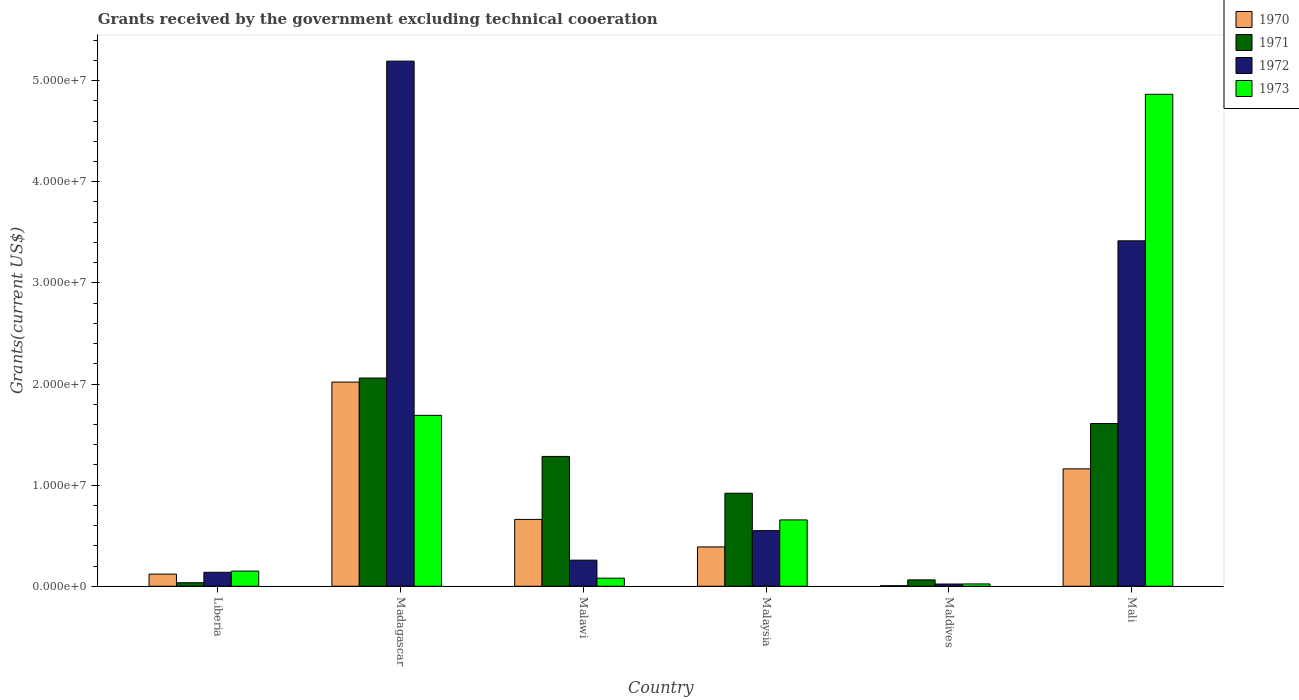How many groups of bars are there?
Keep it short and to the point. 6. Are the number of bars on each tick of the X-axis equal?
Make the answer very short. Yes. What is the label of the 3rd group of bars from the left?
Offer a terse response. Malawi. What is the total grants received by the government in 1972 in Liberia?
Keep it short and to the point. 1.38e+06. Across all countries, what is the maximum total grants received by the government in 1972?
Your response must be concise. 5.19e+07. Across all countries, what is the minimum total grants received by the government in 1970?
Your answer should be compact. 6.00e+04. In which country was the total grants received by the government in 1971 maximum?
Give a very brief answer. Madagascar. In which country was the total grants received by the government in 1970 minimum?
Your response must be concise. Maldives. What is the total total grants received by the government in 1973 in the graph?
Offer a terse response. 7.46e+07. What is the difference between the total grants received by the government in 1972 in Madagascar and that in Malawi?
Ensure brevity in your answer.  4.94e+07. What is the difference between the total grants received by the government in 1971 in Madagascar and the total grants received by the government in 1972 in Maldives?
Ensure brevity in your answer.  2.04e+07. What is the average total grants received by the government in 1970 per country?
Your answer should be very brief. 7.26e+06. What is the difference between the total grants received by the government of/in 1970 and total grants received by the government of/in 1972 in Mali?
Keep it short and to the point. -2.26e+07. In how many countries, is the total grants received by the government in 1973 greater than 28000000 US$?
Your answer should be very brief. 1. What is the ratio of the total grants received by the government in 1970 in Liberia to that in Malaysia?
Your answer should be very brief. 0.31. What is the difference between the highest and the second highest total grants received by the government in 1972?
Ensure brevity in your answer.  4.64e+07. What is the difference between the highest and the lowest total grants received by the government in 1972?
Ensure brevity in your answer.  5.17e+07. In how many countries, is the total grants received by the government in 1972 greater than the average total grants received by the government in 1972 taken over all countries?
Offer a terse response. 2. Is the sum of the total grants received by the government in 1972 in Madagascar and Maldives greater than the maximum total grants received by the government in 1971 across all countries?
Your answer should be very brief. Yes. Is it the case that in every country, the sum of the total grants received by the government in 1972 and total grants received by the government in 1971 is greater than the total grants received by the government in 1970?
Keep it short and to the point. Yes. Are the values on the major ticks of Y-axis written in scientific E-notation?
Give a very brief answer. Yes. Does the graph contain any zero values?
Provide a succinct answer. No. Does the graph contain grids?
Provide a succinct answer. No. How many legend labels are there?
Keep it short and to the point. 4. How are the legend labels stacked?
Keep it short and to the point. Vertical. What is the title of the graph?
Provide a succinct answer. Grants received by the government excluding technical cooeration. Does "1999" appear as one of the legend labels in the graph?
Provide a succinct answer. No. What is the label or title of the Y-axis?
Ensure brevity in your answer.  Grants(current US$). What is the Grants(current US$) in 1970 in Liberia?
Offer a very short reply. 1.20e+06. What is the Grants(current US$) in 1972 in Liberia?
Provide a succinct answer. 1.38e+06. What is the Grants(current US$) in 1973 in Liberia?
Your response must be concise. 1.50e+06. What is the Grants(current US$) of 1970 in Madagascar?
Give a very brief answer. 2.02e+07. What is the Grants(current US$) in 1971 in Madagascar?
Keep it short and to the point. 2.06e+07. What is the Grants(current US$) in 1972 in Madagascar?
Ensure brevity in your answer.  5.19e+07. What is the Grants(current US$) in 1973 in Madagascar?
Offer a terse response. 1.69e+07. What is the Grants(current US$) of 1970 in Malawi?
Keep it short and to the point. 6.61e+06. What is the Grants(current US$) in 1971 in Malawi?
Make the answer very short. 1.28e+07. What is the Grants(current US$) in 1972 in Malawi?
Offer a very short reply. 2.58e+06. What is the Grants(current US$) in 1973 in Malawi?
Provide a short and direct response. 8.00e+05. What is the Grants(current US$) of 1970 in Malaysia?
Your answer should be very brief. 3.89e+06. What is the Grants(current US$) in 1971 in Malaysia?
Provide a short and direct response. 9.20e+06. What is the Grants(current US$) of 1972 in Malaysia?
Make the answer very short. 5.50e+06. What is the Grants(current US$) of 1973 in Malaysia?
Offer a very short reply. 6.56e+06. What is the Grants(current US$) of 1971 in Maldives?
Make the answer very short. 6.30e+05. What is the Grants(current US$) in 1972 in Maldives?
Provide a succinct answer. 2.20e+05. What is the Grants(current US$) of 1970 in Mali?
Give a very brief answer. 1.16e+07. What is the Grants(current US$) of 1971 in Mali?
Your response must be concise. 1.61e+07. What is the Grants(current US$) in 1972 in Mali?
Make the answer very short. 3.42e+07. What is the Grants(current US$) of 1973 in Mali?
Keep it short and to the point. 4.86e+07. Across all countries, what is the maximum Grants(current US$) in 1970?
Your answer should be compact. 2.02e+07. Across all countries, what is the maximum Grants(current US$) in 1971?
Your answer should be very brief. 2.06e+07. Across all countries, what is the maximum Grants(current US$) in 1972?
Offer a very short reply. 5.19e+07. Across all countries, what is the maximum Grants(current US$) in 1973?
Ensure brevity in your answer.  4.86e+07. Across all countries, what is the minimum Grants(current US$) of 1970?
Provide a short and direct response. 6.00e+04. Across all countries, what is the minimum Grants(current US$) of 1971?
Your answer should be compact. 3.50e+05. Across all countries, what is the minimum Grants(current US$) of 1973?
Provide a succinct answer. 2.30e+05. What is the total Grants(current US$) of 1970 in the graph?
Keep it short and to the point. 4.36e+07. What is the total Grants(current US$) of 1971 in the graph?
Make the answer very short. 5.97e+07. What is the total Grants(current US$) in 1972 in the graph?
Your response must be concise. 9.58e+07. What is the total Grants(current US$) of 1973 in the graph?
Offer a terse response. 7.46e+07. What is the difference between the Grants(current US$) in 1970 in Liberia and that in Madagascar?
Provide a short and direct response. -1.90e+07. What is the difference between the Grants(current US$) of 1971 in Liberia and that in Madagascar?
Your answer should be very brief. -2.02e+07. What is the difference between the Grants(current US$) in 1972 in Liberia and that in Madagascar?
Your answer should be compact. -5.06e+07. What is the difference between the Grants(current US$) in 1973 in Liberia and that in Madagascar?
Keep it short and to the point. -1.54e+07. What is the difference between the Grants(current US$) in 1970 in Liberia and that in Malawi?
Offer a very short reply. -5.41e+06. What is the difference between the Grants(current US$) in 1971 in Liberia and that in Malawi?
Ensure brevity in your answer.  -1.25e+07. What is the difference between the Grants(current US$) in 1972 in Liberia and that in Malawi?
Offer a terse response. -1.20e+06. What is the difference between the Grants(current US$) in 1970 in Liberia and that in Malaysia?
Provide a succinct answer. -2.69e+06. What is the difference between the Grants(current US$) of 1971 in Liberia and that in Malaysia?
Offer a very short reply. -8.85e+06. What is the difference between the Grants(current US$) in 1972 in Liberia and that in Malaysia?
Provide a succinct answer. -4.12e+06. What is the difference between the Grants(current US$) of 1973 in Liberia and that in Malaysia?
Give a very brief answer. -5.06e+06. What is the difference between the Grants(current US$) in 1970 in Liberia and that in Maldives?
Ensure brevity in your answer.  1.14e+06. What is the difference between the Grants(current US$) in 1971 in Liberia and that in Maldives?
Keep it short and to the point. -2.80e+05. What is the difference between the Grants(current US$) of 1972 in Liberia and that in Maldives?
Ensure brevity in your answer.  1.16e+06. What is the difference between the Grants(current US$) of 1973 in Liberia and that in Maldives?
Keep it short and to the point. 1.27e+06. What is the difference between the Grants(current US$) of 1970 in Liberia and that in Mali?
Offer a very short reply. -1.04e+07. What is the difference between the Grants(current US$) of 1971 in Liberia and that in Mali?
Give a very brief answer. -1.57e+07. What is the difference between the Grants(current US$) in 1972 in Liberia and that in Mali?
Give a very brief answer. -3.28e+07. What is the difference between the Grants(current US$) of 1973 in Liberia and that in Mali?
Your answer should be compact. -4.72e+07. What is the difference between the Grants(current US$) in 1970 in Madagascar and that in Malawi?
Make the answer very short. 1.36e+07. What is the difference between the Grants(current US$) of 1971 in Madagascar and that in Malawi?
Provide a short and direct response. 7.75e+06. What is the difference between the Grants(current US$) of 1972 in Madagascar and that in Malawi?
Offer a terse response. 4.94e+07. What is the difference between the Grants(current US$) of 1973 in Madagascar and that in Malawi?
Ensure brevity in your answer.  1.61e+07. What is the difference between the Grants(current US$) of 1970 in Madagascar and that in Malaysia?
Give a very brief answer. 1.63e+07. What is the difference between the Grants(current US$) in 1971 in Madagascar and that in Malaysia?
Your answer should be very brief. 1.14e+07. What is the difference between the Grants(current US$) of 1972 in Madagascar and that in Malaysia?
Give a very brief answer. 4.64e+07. What is the difference between the Grants(current US$) of 1973 in Madagascar and that in Malaysia?
Your answer should be compact. 1.03e+07. What is the difference between the Grants(current US$) in 1970 in Madagascar and that in Maldives?
Offer a very short reply. 2.01e+07. What is the difference between the Grants(current US$) of 1971 in Madagascar and that in Maldives?
Offer a terse response. 2.00e+07. What is the difference between the Grants(current US$) in 1972 in Madagascar and that in Maldives?
Give a very brief answer. 5.17e+07. What is the difference between the Grants(current US$) in 1973 in Madagascar and that in Maldives?
Your response must be concise. 1.67e+07. What is the difference between the Grants(current US$) in 1970 in Madagascar and that in Mali?
Make the answer very short. 8.58e+06. What is the difference between the Grants(current US$) of 1971 in Madagascar and that in Mali?
Your answer should be compact. 4.50e+06. What is the difference between the Grants(current US$) of 1972 in Madagascar and that in Mali?
Provide a succinct answer. 1.78e+07. What is the difference between the Grants(current US$) of 1973 in Madagascar and that in Mali?
Offer a terse response. -3.18e+07. What is the difference between the Grants(current US$) of 1970 in Malawi and that in Malaysia?
Your answer should be compact. 2.72e+06. What is the difference between the Grants(current US$) of 1971 in Malawi and that in Malaysia?
Offer a very short reply. 3.64e+06. What is the difference between the Grants(current US$) of 1972 in Malawi and that in Malaysia?
Offer a terse response. -2.92e+06. What is the difference between the Grants(current US$) of 1973 in Malawi and that in Malaysia?
Offer a very short reply. -5.76e+06. What is the difference between the Grants(current US$) in 1970 in Malawi and that in Maldives?
Your response must be concise. 6.55e+06. What is the difference between the Grants(current US$) in 1971 in Malawi and that in Maldives?
Provide a short and direct response. 1.22e+07. What is the difference between the Grants(current US$) in 1972 in Malawi and that in Maldives?
Provide a succinct answer. 2.36e+06. What is the difference between the Grants(current US$) of 1973 in Malawi and that in Maldives?
Ensure brevity in your answer.  5.70e+05. What is the difference between the Grants(current US$) in 1970 in Malawi and that in Mali?
Your response must be concise. -5.00e+06. What is the difference between the Grants(current US$) of 1971 in Malawi and that in Mali?
Your answer should be compact. -3.25e+06. What is the difference between the Grants(current US$) of 1972 in Malawi and that in Mali?
Your answer should be compact. -3.16e+07. What is the difference between the Grants(current US$) in 1973 in Malawi and that in Mali?
Your answer should be very brief. -4.78e+07. What is the difference between the Grants(current US$) of 1970 in Malaysia and that in Maldives?
Keep it short and to the point. 3.83e+06. What is the difference between the Grants(current US$) in 1971 in Malaysia and that in Maldives?
Your answer should be compact. 8.57e+06. What is the difference between the Grants(current US$) in 1972 in Malaysia and that in Maldives?
Provide a succinct answer. 5.28e+06. What is the difference between the Grants(current US$) of 1973 in Malaysia and that in Maldives?
Provide a short and direct response. 6.33e+06. What is the difference between the Grants(current US$) in 1970 in Malaysia and that in Mali?
Offer a terse response. -7.72e+06. What is the difference between the Grants(current US$) of 1971 in Malaysia and that in Mali?
Offer a terse response. -6.89e+06. What is the difference between the Grants(current US$) in 1972 in Malaysia and that in Mali?
Offer a very short reply. -2.87e+07. What is the difference between the Grants(current US$) in 1973 in Malaysia and that in Mali?
Ensure brevity in your answer.  -4.21e+07. What is the difference between the Grants(current US$) of 1970 in Maldives and that in Mali?
Your response must be concise. -1.16e+07. What is the difference between the Grants(current US$) of 1971 in Maldives and that in Mali?
Provide a short and direct response. -1.55e+07. What is the difference between the Grants(current US$) of 1972 in Maldives and that in Mali?
Offer a very short reply. -3.39e+07. What is the difference between the Grants(current US$) of 1973 in Maldives and that in Mali?
Your answer should be compact. -4.84e+07. What is the difference between the Grants(current US$) of 1970 in Liberia and the Grants(current US$) of 1971 in Madagascar?
Keep it short and to the point. -1.94e+07. What is the difference between the Grants(current US$) in 1970 in Liberia and the Grants(current US$) in 1972 in Madagascar?
Offer a very short reply. -5.07e+07. What is the difference between the Grants(current US$) of 1970 in Liberia and the Grants(current US$) of 1973 in Madagascar?
Give a very brief answer. -1.57e+07. What is the difference between the Grants(current US$) in 1971 in Liberia and the Grants(current US$) in 1972 in Madagascar?
Your answer should be very brief. -5.16e+07. What is the difference between the Grants(current US$) of 1971 in Liberia and the Grants(current US$) of 1973 in Madagascar?
Provide a succinct answer. -1.66e+07. What is the difference between the Grants(current US$) in 1972 in Liberia and the Grants(current US$) in 1973 in Madagascar?
Your response must be concise. -1.55e+07. What is the difference between the Grants(current US$) in 1970 in Liberia and the Grants(current US$) in 1971 in Malawi?
Offer a very short reply. -1.16e+07. What is the difference between the Grants(current US$) of 1970 in Liberia and the Grants(current US$) of 1972 in Malawi?
Your answer should be very brief. -1.38e+06. What is the difference between the Grants(current US$) in 1971 in Liberia and the Grants(current US$) in 1972 in Malawi?
Make the answer very short. -2.23e+06. What is the difference between the Grants(current US$) of 1971 in Liberia and the Grants(current US$) of 1973 in Malawi?
Your answer should be very brief. -4.50e+05. What is the difference between the Grants(current US$) in 1972 in Liberia and the Grants(current US$) in 1973 in Malawi?
Keep it short and to the point. 5.80e+05. What is the difference between the Grants(current US$) of 1970 in Liberia and the Grants(current US$) of 1971 in Malaysia?
Your answer should be compact. -8.00e+06. What is the difference between the Grants(current US$) of 1970 in Liberia and the Grants(current US$) of 1972 in Malaysia?
Your answer should be very brief. -4.30e+06. What is the difference between the Grants(current US$) in 1970 in Liberia and the Grants(current US$) in 1973 in Malaysia?
Your answer should be very brief. -5.36e+06. What is the difference between the Grants(current US$) of 1971 in Liberia and the Grants(current US$) of 1972 in Malaysia?
Your response must be concise. -5.15e+06. What is the difference between the Grants(current US$) in 1971 in Liberia and the Grants(current US$) in 1973 in Malaysia?
Make the answer very short. -6.21e+06. What is the difference between the Grants(current US$) in 1972 in Liberia and the Grants(current US$) in 1973 in Malaysia?
Give a very brief answer. -5.18e+06. What is the difference between the Grants(current US$) of 1970 in Liberia and the Grants(current US$) of 1971 in Maldives?
Offer a terse response. 5.70e+05. What is the difference between the Grants(current US$) of 1970 in Liberia and the Grants(current US$) of 1972 in Maldives?
Ensure brevity in your answer.  9.80e+05. What is the difference between the Grants(current US$) in 1970 in Liberia and the Grants(current US$) in 1973 in Maldives?
Your answer should be very brief. 9.70e+05. What is the difference between the Grants(current US$) in 1971 in Liberia and the Grants(current US$) in 1972 in Maldives?
Offer a very short reply. 1.30e+05. What is the difference between the Grants(current US$) of 1971 in Liberia and the Grants(current US$) of 1973 in Maldives?
Make the answer very short. 1.20e+05. What is the difference between the Grants(current US$) of 1972 in Liberia and the Grants(current US$) of 1973 in Maldives?
Your answer should be very brief. 1.15e+06. What is the difference between the Grants(current US$) of 1970 in Liberia and the Grants(current US$) of 1971 in Mali?
Make the answer very short. -1.49e+07. What is the difference between the Grants(current US$) in 1970 in Liberia and the Grants(current US$) in 1972 in Mali?
Your answer should be very brief. -3.30e+07. What is the difference between the Grants(current US$) in 1970 in Liberia and the Grants(current US$) in 1973 in Mali?
Give a very brief answer. -4.74e+07. What is the difference between the Grants(current US$) of 1971 in Liberia and the Grants(current US$) of 1972 in Mali?
Your response must be concise. -3.38e+07. What is the difference between the Grants(current US$) of 1971 in Liberia and the Grants(current US$) of 1973 in Mali?
Make the answer very short. -4.83e+07. What is the difference between the Grants(current US$) in 1972 in Liberia and the Grants(current US$) in 1973 in Mali?
Your answer should be very brief. -4.73e+07. What is the difference between the Grants(current US$) of 1970 in Madagascar and the Grants(current US$) of 1971 in Malawi?
Offer a terse response. 7.35e+06. What is the difference between the Grants(current US$) in 1970 in Madagascar and the Grants(current US$) in 1972 in Malawi?
Provide a short and direct response. 1.76e+07. What is the difference between the Grants(current US$) of 1970 in Madagascar and the Grants(current US$) of 1973 in Malawi?
Ensure brevity in your answer.  1.94e+07. What is the difference between the Grants(current US$) in 1971 in Madagascar and the Grants(current US$) in 1972 in Malawi?
Provide a short and direct response. 1.80e+07. What is the difference between the Grants(current US$) in 1971 in Madagascar and the Grants(current US$) in 1973 in Malawi?
Provide a short and direct response. 1.98e+07. What is the difference between the Grants(current US$) in 1972 in Madagascar and the Grants(current US$) in 1973 in Malawi?
Make the answer very short. 5.11e+07. What is the difference between the Grants(current US$) of 1970 in Madagascar and the Grants(current US$) of 1971 in Malaysia?
Keep it short and to the point. 1.10e+07. What is the difference between the Grants(current US$) of 1970 in Madagascar and the Grants(current US$) of 1972 in Malaysia?
Your answer should be very brief. 1.47e+07. What is the difference between the Grants(current US$) of 1970 in Madagascar and the Grants(current US$) of 1973 in Malaysia?
Make the answer very short. 1.36e+07. What is the difference between the Grants(current US$) in 1971 in Madagascar and the Grants(current US$) in 1972 in Malaysia?
Ensure brevity in your answer.  1.51e+07. What is the difference between the Grants(current US$) of 1971 in Madagascar and the Grants(current US$) of 1973 in Malaysia?
Your answer should be very brief. 1.40e+07. What is the difference between the Grants(current US$) of 1972 in Madagascar and the Grants(current US$) of 1973 in Malaysia?
Offer a terse response. 4.54e+07. What is the difference between the Grants(current US$) of 1970 in Madagascar and the Grants(current US$) of 1971 in Maldives?
Your answer should be compact. 1.96e+07. What is the difference between the Grants(current US$) in 1970 in Madagascar and the Grants(current US$) in 1972 in Maldives?
Your response must be concise. 2.00e+07. What is the difference between the Grants(current US$) in 1970 in Madagascar and the Grants(current US$) in 1973 in Maldives?
Provide a succinct answer. 2.00e+07. What is the difference between the Grants(current US$) of 1971 in Madagascar and the Grants(current US$) of 1972 in Maldives?
Keep it short and to the point. 2.04e+07. What is the difference between the Grants(current US$) of 1971 in Madagascar and the Grants(current US$) of 1973 in Maldives?
Your answer should be very brief. 2.04e+07. What is the difference between the Grants(current US$) in 1972 in Madagascar and the Grants(current US$) in 1973 in Maldives?
Keep it short and to the point. 5.17e+07. What is the difference between the Grants(current US$) of 1970 in Madagascar and the Grants(current US$) of 1971 in Mali?
Provide a short and direct response. 4.10e+06. What is the difference between the Grants(current US$) in 1970 in Madagascar and the Grants(current US$) in 1972 in Mali?
Your answer should be compact. -1.40e+07. What is the difference between the Grants(current US$) in 1970 in Madagascar and the Grants(current US$) in 1973 in Mali?
Your answer should be compact. -2.85e+07. What is the difference between the Grants(current US$) of 1971 in Madagascar and the Grants(current US$) of 1972 in Mali?
Your answer should be compact. -1.36e+07. What is the difference between the Grants(current US$) of 1971 in Madagascar and the Grants(current US$) of 1973 in Mali?
Your response must be concise. -2.81e+07. What is the difference between the Grants(current US$) of 1972 in Madagascar and the Grants(current US$) of 1973 in Mali?
Keep it short and to the point. 3.28e+06. What is the difference between the Grants(current US$) of 1970 in Malawi and the Grants(current US$) of 1971 in Malaysia?
Your response must be concise. -2.59e+06. What is the difference between the Grants(current US$) in 1970 in Malawi and the Grants(current US$) in 1972 in Malaysia?
Make the answer very short. 1.11e+06. What is the difference between the Grants(current US$) in 1970 in Malawi and the Grants(current US$) in 1973 in Malaysia?
Offer a terse response. 5.00e+04. What is the difference between the Grants(current US$) in 1971 in Malawi and the Grants(current US$) in 1972 in Malaysia?
Provide a succinct answer. 7.34e+06. What is the difference between the Grants(current US$) of 1971 in Malawi and the Grants(current US$) of 1973 in Malaysia?
Provide a short and direct response. 6.28e+06. What is the difference between the Grants(current US$) in 1972 in Malawi and the Grants(current US$) in 1973 in Malaysia?
Your answer should be very brief. -3.98e+06. What is the difference between the Grants(current US$) of 1970 in Malawi and the Grants(current US$) of 1971 in Maldives?
Offer a very short reply. 5.98e+06. What is the difference between the Grants(current US$) in 1970 in Malawi and the Grants(current US$) in 1972 in Maldives?
Offer a very short reply. 6.39e+06. What is the difference between the Grants(current US$) of 1970 in Malawi and the Grants(current US$) of 1973 in Maldives?
Give a very brief answer. 6.38e+06. What is the difference between the Grants(current US$) in 1971 in Malawi and the Grants(current US$) in 1972 in Maldives?
Ensure brevity in your answer.  1.26e+07. What is the difference between the Grants(current US$) in 1971 in Malawi and the Grants(current US$) in 1973 in Maldives?
Offer a very short reply. 1.26e+07. What is the difference between the Grants(current US$) of 1972 in Malawi and the Grants(current US$) of 1973 in Maldives?
Offer a terse response. 2.35e+06. What is the difference between the Grants(current US$) of 1970 in Malawi and the Grants(current US$) of 1971 in Mali?
Provide a short and direct response. -9.48e+06. What is the difference between the Grants(current US$) of 1970 in Malawi and the Grants(current US$) of 1972 in Mali?
Provide a succinct answer. -2.76e+07. What is the difference between the Grants(current US$) in 1970 in Malawi and the Grants(current US$) in 1973 in Mali?
Keep it short and to the point. -4.20e+07. What is the difference between the Grants(current US$) of 1971 in Malawi and the Grants(current US$) of 1972 in Mali?
Offer a very short reply. -2.13e+07. What is the difference between the Grants(current US$) of 1971 in Malawi and the Grants(current US$) of 1973 in Mali?
Keep it short and to the point. -3.58e+07. What is the difference between the Grants(current US$) in 1972 in Malawi and the Grants(current US$) in 1973 in Mali?
Your answer should be very brief. -4.61e+07. What is the difference between the Grants(current US$) in 1970 in Malaysia and the Grants(current US$) in 1971 in Maldives?
Provide a short and direct response. 3.26e+06. What is the difference between the Grants(current US$) in 1970 in Malaysia and the Grants(current US$) in 1972 in Maldives?
Your answer should be compact. 3.67e+06. What is the difference between the Grants(current US$) in 1970 in Malaysia and the Grants(current US$) in 1973 in Maldives?
Your answer should be very brief. 3.66e+06. What is the difference between the Grants(current US$) of 1971 in Malaysia and the Grants(current US$) of 1972 in Maldives?
Provide a short and direct response. 8.98e+06. What is the difference between the Grants(current US$) of 1971 in Malaysia and the Grants(current US$) of 1973 in Maldives?
Keep it short and to the point. 8.97e+06. What is the difference between the Grants(current US$) of 1972 in Malaysia and the Grants(current US$) of 1973 in Maldives?
Offer a very short reply. 5.27e+06. What is the difference between the Grants(current US$) of 1970 in Malaysia and the Grants(current US$) of 1971 in Mali?
Your answer should be compact. -1.22e+07. What is the difference between the Grants(current US$) of 1970 in Malaysia and the Grants(current US$) of 1972 in Mali?
Your response must be concise. -3.03e+07. What is the difference between the Grants(current US$) in 1970 in Malaysia and the Grants(current US$) in 1973 in Mali?
Make the answer very short. -4.48e+07. What is the difference between the Grants(current US$) in 1971 in Malaysia and the Grants(current US$) in 1972 in Mali?
Your response must be concise. -2.50e+07. What is the difference between the Grants(current US$) of 1971 in Malaysia and the Grants(current US$) of 1973 in Mali?
Your answer should be compact. -3.94e+07. What is the difference between the Grants(current US$) in 1972 in Malaysia and the Grants(current US$) in 1973 in Mali?
Give a very brief answer. -4.32e+07. What is the difference between the Grants(current US$) of 1970 in Maldives and the Grants(current US$) of 1971 in Mali?
Give a very brief answer. -1.60e+07. What is the difference between the Grants(current US$) in 1970 in Maldives and the Grants(current US$) in 1972 in Mali?
Your answer should be compact. -3.41e+07. What is the difference between the Grants(current US$) of 1970 in Maldives and the Grants(current US$) of 1973 in Mali?
Offer a terse response. -4.86e+07. What is the difference between the Grants(current US$) in 1971 in Maldives and the Grants(current US$) in 1972 in Mali?
Provide a succinct answer. -3.35e+07. What is the difference between the Grants(current US$) in 1971 in Maldives and the Grants(current US$) in 1973 in Mali?
Your response must be concise. -4.80e+07. What is the difference between the Grants(current US$) in 1972 in Maldives and the Grants(current US$) in 1973 in Mali?
Keep it short and to the point. -4.84e+07. What is the average Grants(current US$) in 1970 per country?
Your answer should be very brief. 7.26e+06. What is the average Grants(current US$) in 1971 per country?
Offer a terse response. 9.95e+06. What is the average Grants(current US$) of 1972 per country?
Your answer should be compact. 1.60e+07. What is the average Grants(current US$) of 1973 per country?
Your answer should be compact. 1.24e+07. What is the difference between the Grants(current US$) of 1970 and Grants(current US$) of 1971 in Liberia?
Keep it short and to the point. 8.50e+05. What is the difference between the Grants(current US$) of 1970 and Grants(current US$) of 1972 in Liberia?
Your answer should be very brief. -1.80e+05. What is the difference between the Grants(current US$) of 1971 and Grants(current US$) of 1972 in Liberia?
Give a very brief answer. -1.03e+06. What is the difference between the Grants(current US$) of 1971 and Grants(current US$) of 1973 in Liberia?
Provide a short and direct response. -1.15e+06. What is the difference between the Grants(current US$) of 1972 and Grants(current US$) of 1973 in Liberia?
Offer a terse response. -1.20e+05. What is the difference between the Grants(current US$) in 1970 and Grants(current US$) in 1971 in Madagascar?
Make the answer very short. -4.00e+05. What is the difference between the Grants(current US$) of 1970 and Grants(current US$) of 1972 in Madagascar?
Ensure brevity in your answer.  -3.17e+07. What is the difference between the Grants(current US$) in 1970 and Grants(current US$) in 1973 in Madagascar?
Offer a very short reply. 3.29e+06. What is the difference between the Grants(current US$) of 1971 and Grants(current US$) of 1972 in Madagascar?
Keep it short and to the point. -3.13e+07. What is the difference between the Grants(current US$) of 1971 and Grants(current US$) of 1973 in Madagascar?
Keep it short and to the point. 3.69e+06. What is the difference between the Grants(current US$) of 1972 and Grants(current US$) of 1973 in Madagascar?
Provide a succinct answer. 3.50e+07. What is the difference between the Grants(current US$) in 1970 and Grants(current US$) in 1971 in Malawi?
Provide a short and direct response. -6.23e+06. What is the difference between the Grants(current US$) of 1970 and Grants(current US$) of 1972 in Malawi?
Offer a terse response. 4.03e+06. What is the difference between the Grants(current US$) in 1970 and Grants(current US$) in 1973 in Malawi?
Your answer should be compact. 5.81e+06. What is the difference between the Grants(current US$) of 1971 and Grants(current US$) of 1972 in Malawi?
Provide a succinct answer. 1.03e+07. What is the difference between the Grants(current US$) in 1971 and Grants(current US$) in 1973 in Malawi?
Keep it short and to the point. 1.20e+07. What is the difference between the Grants(current US$) of 1972 and Grants(current US$) of 1973 in Malawi?
Make the answer very short. 1.78e+06. What is the difference between the Grants(current US$) in 1970 and Grants(current US$) in 1971 in Malaysia?
Offer a very short reply. -5.31e+06. What is the difference between the Grants(current US$) of 1970 and Grants(current US$) of 1972 in Malaysia?
Your answer should be very brief. -1.61e+06. What is the difference between the Grants(current US$) of 1970 and Grants(current US$) of 1973 in Malaysia?
Keep it short and to the point. -2.67e+06. What is the difference between the Grants(current US$) in 1971 and Grants(current US$) in 1972 in Malaysia?
Your answer should be compact. 3.70e+06. What is the difference between the Grants(current US$) of 1971 and Grants(current US$) of 1973 in Malaysia?
Your response must be concise. 2.64e+06. What is the difference between the Grants(current US$) of 1972 and Grants(current US$) of 1973 in Malaysia?
Make the answer very short. -1.06e+06. What is the difference between the Grants(current US$) of 1970 and Grants(current US$) of 1971 in Maldives?
Your answer should be compact. -5.70e+05. What is the difference between the Grants(current US$) of 1970 and Grants(current US$) of 1973 in Maldives?
Your answer should be compact. -1.70e+05. What is the difference between the Grants(current US$) of 1972 and Grants(current US$) of 1973 in Maldives?
Ensure brevity in your answer.  -10000. What is the difference between the Grants(current US$) of 1970 and Grants(current US$) of 1971 in Mali?
Make the answer very short. -4.48e+06. What is the difference between the Grants(current US$) in 1970 and Grants(current US$) in 1972 in Mali?
Make the answer very short. -2.26e+07. What is the difference between the Grants(current US$) in 1970 and Grants(current US$) in 1973 in Mali?
Ensure brevity in your answer.  -3.70e+07. What is the difference between the Grants(current US$) in 1971 and Grants(current US$) in 1972 in Mali?
Ensure brevity in your answer.  -1.81e+07. What is the difference between the Grants(current US$) in 1971 and Grants(current US$) in 1973 in Mali?
Make the answer very short. -3.26e+07. What is the difference between the Grants(current US$) in 1972 and Grants(current US$) in 1973 in Mali?
Your answer should be very brief. -1.45e+07. What is the ratio of the Grants(current US$) of 1970 in Liberia to that in Madagascar?
Provide a short and direct response. 0.06. What is the ratio of the Grants(current US$) of 1971 in Liberia to that in Madagascar?
Provide a short and direct response. 0.02. What is the ratio of the Grants(current US$) in 1972 in Liberia to that in Madagascar?
Offer a terse response. 0.03. What is the ratio of the Grants(current US$) of 1973 in Liberia to that in Madagascar?
Offer a very short reply. 0.09. What is the ratio of the Grants(current US$) in 1970 in Liberia to that in Malawi?
Ensure brevity in your answer.  0.18. What is the ratio of the Grants(current US$) in 1971 in Liberia to that in Malawi?
Provide a short and direct response. 0.03. What is the ratio of the Grants(current US$) in 1972 in Liberia to that in Malawi?
Your response must be concise. 0.53. What is the ratio of the Grants(current US$) of 1973 in Liberia to that in Malawi?
Keep it short and to the point. 1.88. What is the ratio of the Grants(current US$) of 1970 in Liberia to that in Malaysia?
Your answer should be very brief. 0.31. What is the ratio of the Grants(current US$) in 1971 in Liberia to that in Malaysia?
Your response must be concise. 0.04. What is the ratio of the Grants(current US$) of 1972 in Liberia to that in Malaysia?
Keep it short and to the point. 0.25. What is the ratio of the Grants(current US$) in 1973 in Liberia to that in Malaysia?
Your answer should be compact. 0.23. What is the ratio of the Grants(current US$) in 1970 in Liberia to that in Maldives?
Provide a succinct answer. 20. What is the ratio of the Grants(current US$) in 1971 in Liberia to that in Maldives?
Provide a succinct answer. 0.56. What is the ratio of the Grants(current US$) of 1972 in Liberia to that in Maldives?
Provide a short and direct response. 6.27. What is the ratio of the Grants(current US$) in 1973 in Liberia to that in Maldives?
Ensure brevity in your answer.  6.52. What is the ratio of the Grants(current US$) of 1970 in Liberia to that in Mali?
Make the answer very short. 0.1. What is the ratio of the Grants(current US$) of 1971 in Liberia to that in Mali?
Give a very brief answer. 0.02. What is the ratio of the Grants(current US$) of 1972 in Liberia to that in Mali?
Provide a short and direct response. 0.04. What is the ratio of the Grants(current US$) of 1973 in Liberia to that in Mali?
Provide a succinct answer. 0.03. What is the ratio of the Grants(current US$) in 1970 in Madagascar to that in Malawi?
Your answer should be very brief. 3.05. What is the ratio of the Grants(current US$) of 1971 in Madagascar to that in Malawi?
Make the answer very short. 1.6. What is the ratio of the Grants(current US$) in 1972 in Madagascar to that in Malawi?
Offer a very short reply. 20.13. What is the ratio of the Grants(current US$) in 1973 in Madagascar to that in Malawi?
Give a very brief answer. 21.12. What is the ratio of the Grants(current US$) in 1970 in Madagascar to that in Malaysia?
Keep it short and to the point. 5.19. What is the ratio of the Grants(current US$) of 1971 in Madagascar to that in Malaysia?
Offer a very short reply. 2.24. What is the ratio of the Grants(current US$) of 1972 in Madagascar to that in Malaysia?
Ensure brevity in your answer.  9.44. What is the ratio of the Grants(current US$) in 1973 in Madagascar to that in Malaysia?
Provide a short and direct response. 2.58. What is the ratio of the Grants(current US$) in 1970 in Madagascar to that in Maldives?
Offer a very short reply. 336.5. What is the ratio of the Grants(current US$) in 1971 in Madagascar to that in Maldives?
Make the answer very short. 32.68. What is the ratio of the Grants(current US$) of 1972 in Madagascar to that in Maldives?
Give a very brief answer. 236.05. What is the ratio of the Grants(current US$) of 1973 in Madagascar to that in Maldives?
Your response must be concise. 73.48. What is the ratio of the Grants(current US$) of 1970 in Madagascar to that in Mali?
Your answer should be compact. 1.74. What is the ratio of the Grants(current US$) in 1971 in Madagascar to that in Mali?
Your answer should be very brief. 1.28. What is the ratio of the Grants(current US$) in 1972 in Madagascar to that in Mali?
Provide a short and direct response. 1.52. What is the ratio of the Grants(current US$) in 1973 in Madagascar to that in Mali?
Your answer should be very brief. 0.35. What is the ratio of the Grants(current US$) of 1970 in Malawi to that in Malaysia?
Offer a terse response. 1.7. What is the ratio of the Grants(current US$) of 1971 in Malawi to that in Malaysia?
Your answer should be very brief. 1.4. What is the ratio of the Grants(current US$) of 1972 in Malawi to that in Malaysia?
Offer a terse response. 0.47. What is the ratio of the Grants(current US$) in 1973 in Malawi to that in Malaysia?
Offer a very short reply. 0.12. What is the ratio of the Grants(current US$) in 1970 in Malawi to that in Maldives?
Offer a terse response. 110.17. What is the ratio of the Grants(current US$) of 1971 in Malawi to that in Maldives?
Provide a short and direct response. 20.38. What is the ratio of the Grants(current US$) of 1972 in Malawi to that in Maldives?
Offer a terse response. 11.73. What is the ratio of the Grants(current US$) in 1973 in Malawi to that in Maldives?
Make the answer very short. 3.48. What is the ratio of the Grants(current US$) of 1970 in Malawi to that in Mali?
Your response must be concise. 0.57. What is the ratio of the Grants(current US$) in 1971 in Malawi to that in Mali?
Your answer should be very brief. 0.8. What is the ratio of the Grants(current US$) in 1972 in Malawi to that in Mali?
Make the answer very short. 0.08. What is the ratio of the Grants(current US$) in 1973 in Malawi to that in Mali?
Your response must be concise. 0.02. What is the ratio of the Grants(current US$) in 1970 in Malaysia to that in Maldives?
Ensure brevity in your answer.  64.83. What is the ratio of the Grants(current US$) of 1971 in Malaysia to that in Maldives?
Your answer should be compact. 14.6. What is the ratio of the Grants(current US$) of 1973 in Malaysia to that in Maldives?
Offer a very short reply. 28.52. What is the ratio of the Grants(current US$) of 1970 in Malaysia to that in Mali?
Your response must be concise. 0.34. What is the ratio of the Grants(current US$) of 1971 in Malaysia to that in Mali?
Keep it short and to the point. 0.57. What is the ratio of the Grants(current US$) of 1972 in Malaysia to that in Mali?
Keep it short and to the point. 0.16. What is the ratio of the Grants(current US$) of 1973 in Malaysia to that in Mali?
Offer a terse response. 0.13. What is the ratio of the Grants(current US$) of 1970 in Maldives to that in Mali?
Your answer should be compact. 0.01. What is the ratio of the Grants(current US$) in 1971 in Maldives to that in Mali?
Provide a short and direct response. 0.04. What is the ratio of the Grants(current US$) of 1972 in Maldives to that in Mali?
Offer a very short reply. 0.01. What is the ratio of the Grants(current US$) of 1973 in Maldives to that in Mali?
Your response must be concise. 0. What is the difference between the highest and the second highest Grants(current US$) in 1970?
Give a very brief answer. 8.58e+06. What is the difference between the highest and the second highest Grants(current US$) in 1971?
Provide a succinct answer. 4.50e+06. What is the difference between the highest and the second highest Grants(current US$) in 1972?
Make the answer very short. 1.78e+07. What is the difference between the highest and the second highest Grants(current US$) in 1973?
Provide a succinct answer. 3.18e+07. What is the difference between the highest and the lowest Grants(current US$) of 1970?
Make the answer very short. 2.01e+07. What is the difference between the highest and the lowest Grants(current US$) of 1971?
Your answer should be very brief. 2.02e+07. What is the difference between the highest and the lowest Grants(current US$) in 1972?
Offer a very short reply. 5.17e+07. What is the difference between the highest and the lowest Grants(current US$) of 1973?
Make the answer very short. 4.84e+07. 